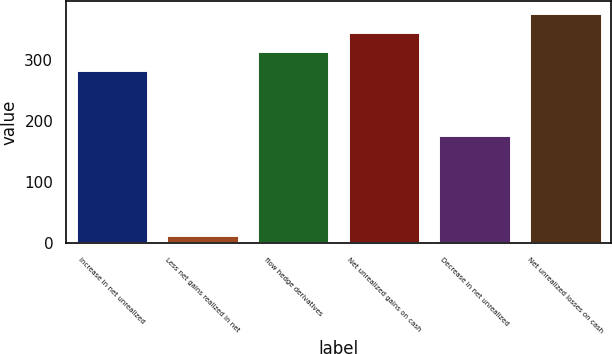Convert chart to OTSL. <chart><loc_0><loc_0><loc_500><loc_500><bar_chart><fcel>Increase in net unrealized<fcel>Less net gains realized in net<fcel>flow hedge derivatives<fcel>Net unrealized gains on cash<fcel>Decrease in net unrealized<fcel>Net unrealized losses on cash<nl><fcel>283<fcel>14<fcel>314.5<fcel>346<fcel>178<fcel>377.5<nl></chart> 